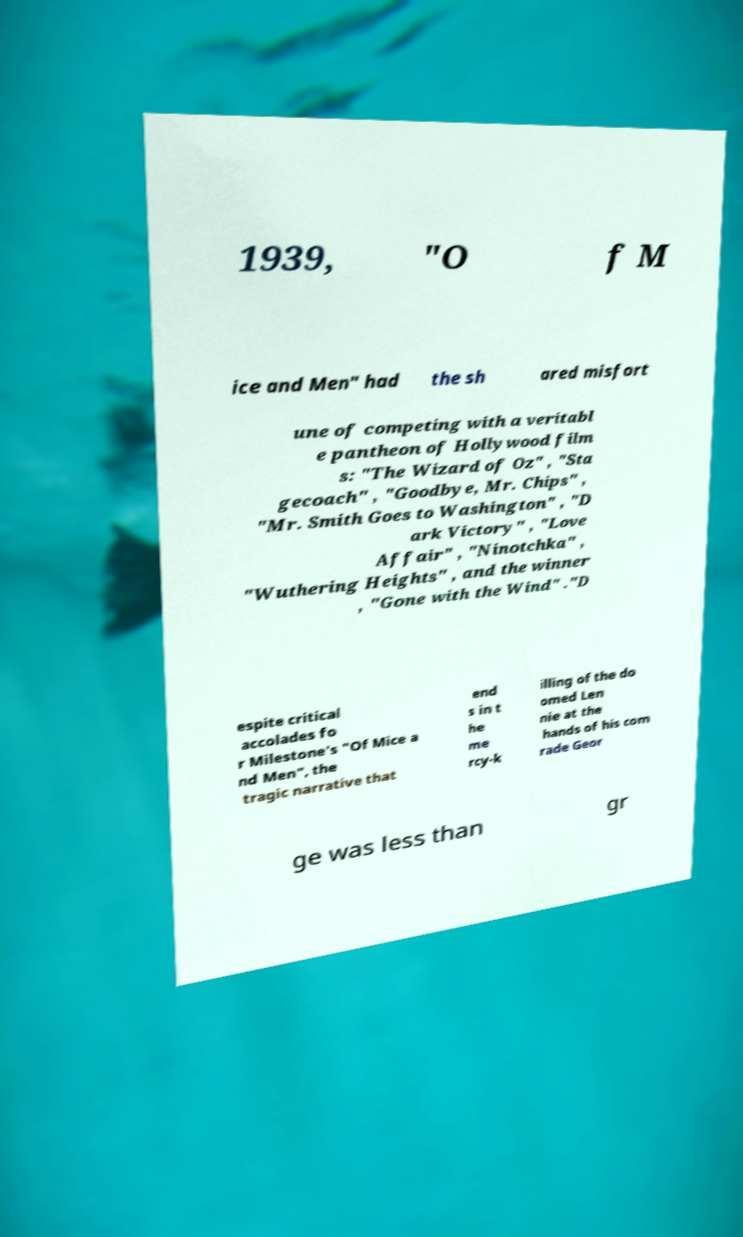Can you accurately transcribe the text from the provided image for me? 1939, "O f M ice and Men" had the sh ared misfort une of competing with a veritabl e pantheon of Hollywood film s: "The Wizard of Oz" , "Sta gecoach" , "Goodbye, Mr. Chips" , "Mr. Smith Goes to Washington" , "D ark Victory" , "Love Affair" , "Ninotchka" , "Wuthering Heights" , and the winner , "Gone with the Wind" ."D espite critical accolades fo r Milestone's "Of Mice a nd Men", the tragic narrative that end s in t he me rcy-k illing of the do omed Len nie at the hands of his com rade Geor ge was less than gr 